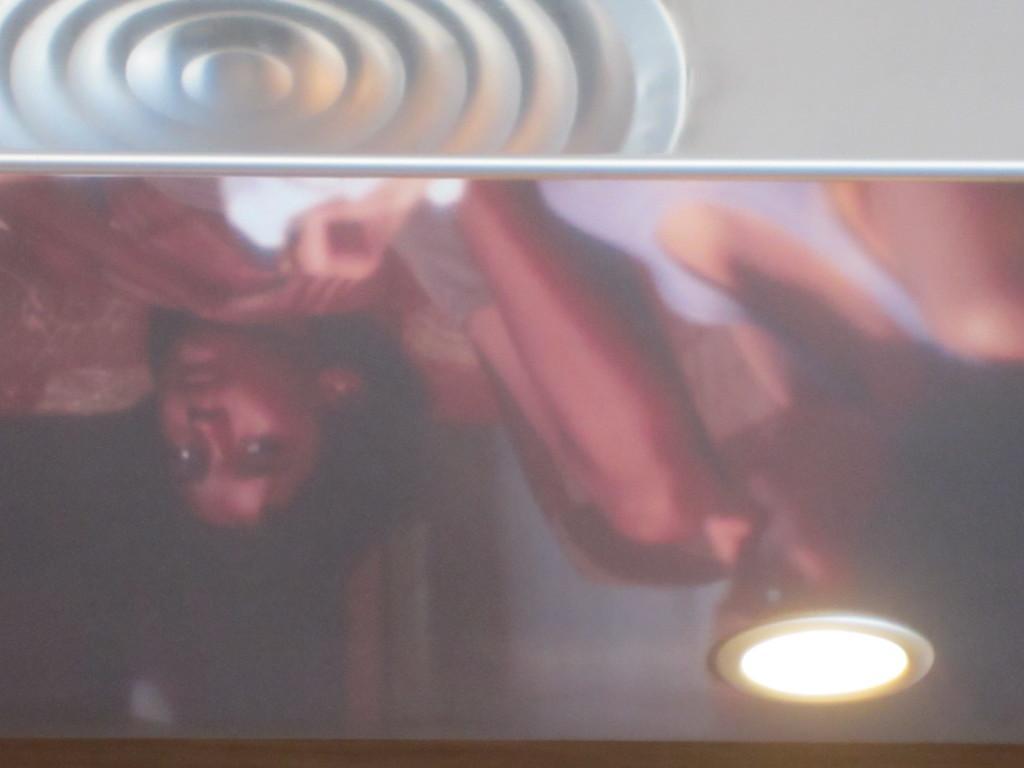In one or two sentences, can you explain what this image depicts? In this image, we can see persons reflections. There is a light in the bottom right of the image. There is a design at the top of the image. 